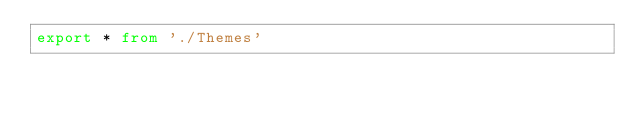<code> <loc_0><loc_0><loc_500><loc_500><_TypeScript_>export * from './Themes'</code> 